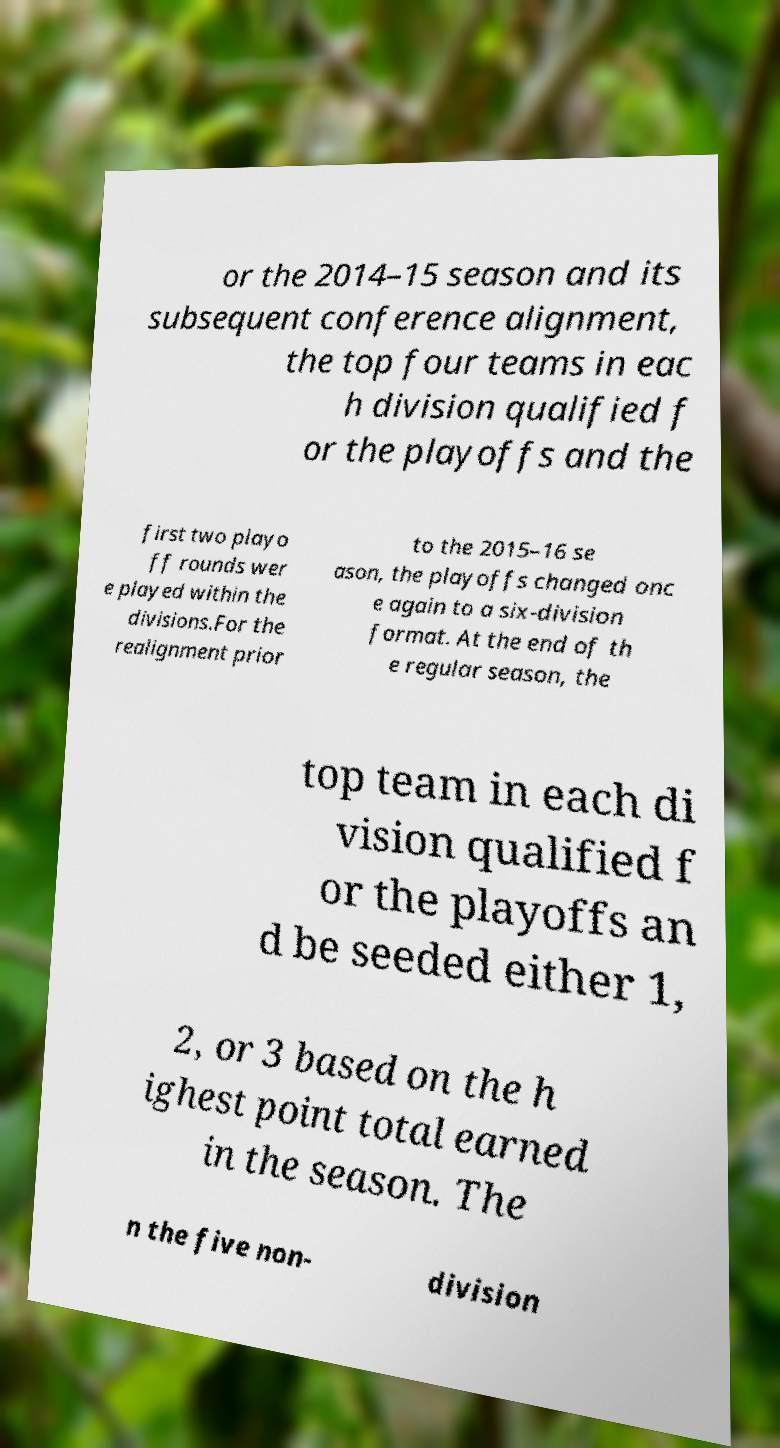Could you extract and type out the text from this image? or the 2014–15 season and its subsequent conference alignment, the top four teams in eac h division qualified f or the playoffs and the first two playo ff rounds wer e played within the divisions.For the realignment prior to the 2015–16 se ason, the playoffs changed onc e again to a six-division format. At the end of th e regular season, the top team in each di vision qualified f or the playoffs an d be seeded either 1, 2, or 3 based on the h ighest point total earned in the season. The n the five non- division 